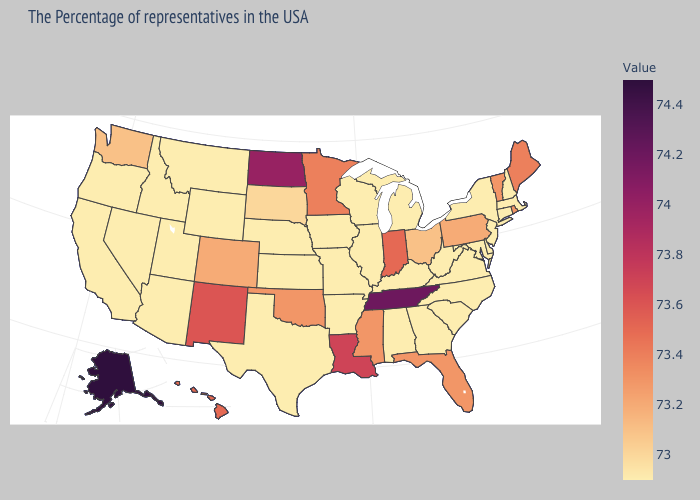Among the states that border Montana , which have the highest value?
Keep it brief. North Dakota. Does Ohio have a higher value than Idaho?
Write a very short answer. Yes. Among the states that border Louisiana , which have the lowest value?
Give a very brief answer. Arkansas, Texas. Does Maine have the highest value in the USA?
Keep it brief. No. Does Alaska have the highest value in the USA?
Concise answer only. Yes. Does Nevada have a lower value than Indiana?
Quick response, please. Yes. Does Iowa have a lower value than Vermont?
Be succinct. Yes. 